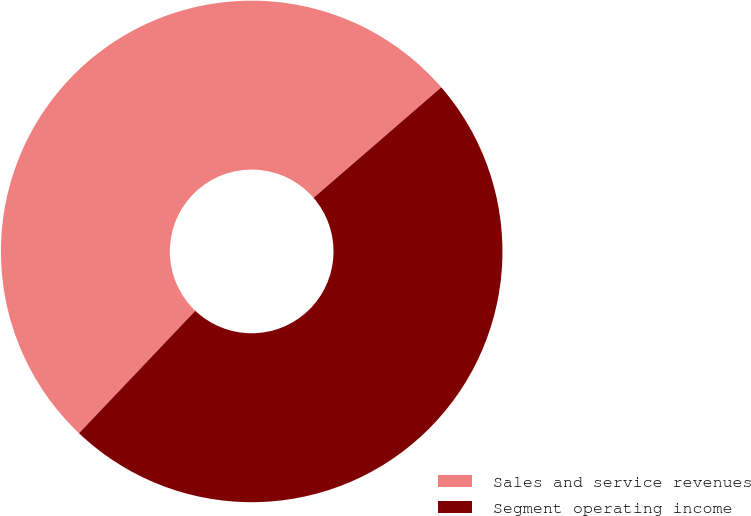Convert chart to OTSL. <chart><loc_0><loc_0><loc_500><loc_500><pie_chart><fcel>Sales and service revenues<fcel>Segment operating income<nl><fcel>51.55%<fcel>48.45%<nl></chart> 